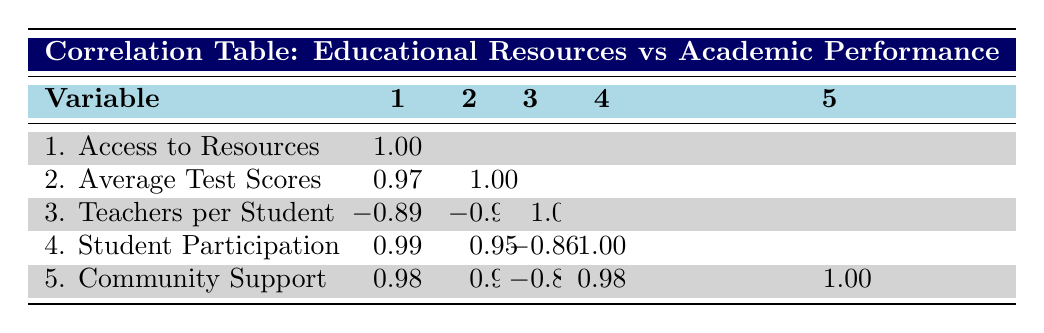What is the correlation between access to resources and average test scores? The table shows a correlation coefficient of 0.97 between access to resources and average test scores. This suggests a very strong positive relationship; as access to resources increases, average test scores tend to increase as well.
Answer: 0.97 Which school has the highest average test scores? According to the data, Parker Elementary School has the highest average test score of 82.
Answer: 82 Does a higher number of teachers per student correlate positively with average test scores? The correlation coefficient between teachers per student and average test scores is -0.94, indicating a strong negative relationship. This means that as the number of teachers per student increases, average test scores tend to decrease.
Answer: No What is the average student participation in programs across all schools? The average student participation can be calculated by summing the participation rates for each school (0.60 + 0.45 + 0.70 + 0.30 + 0.35 + 0.55 = 2.95) and dividing by the number of schools, which is 6. So, 2.95 / 6 = 0.492, approximately 0.49.
Answer: 0.49 Is there a correlation between community support and average test scores? The table indicates a correlation coefficient of 0.93 between community support and average test scores. This suggests a strong positive correlation; as community support increases, average test scores also tend to increase.
Answer: Yes Which school has the lowest access to educational resources? Washington High School has the lowest access to resources, with a score of 2.8.
Answer: 2.8 What is the difference in average test scores between the school with the highest and the school with the lowest access to resources? Parker Elementary (access 5.0, test scores 82) has the highest access while Washington High (access 2.8, test scores 69) has the lowest. The difference in average test scores is calculated as 82 - 69 = 13.
Answer: 13 How does student participation in programs correlate with community support? The correlation coefficient between student participation in programs and community support is 0.98, indicating a very strong positive relationship. Higher participation in programs tends to correlate with better community support.
Answer: 0.98 